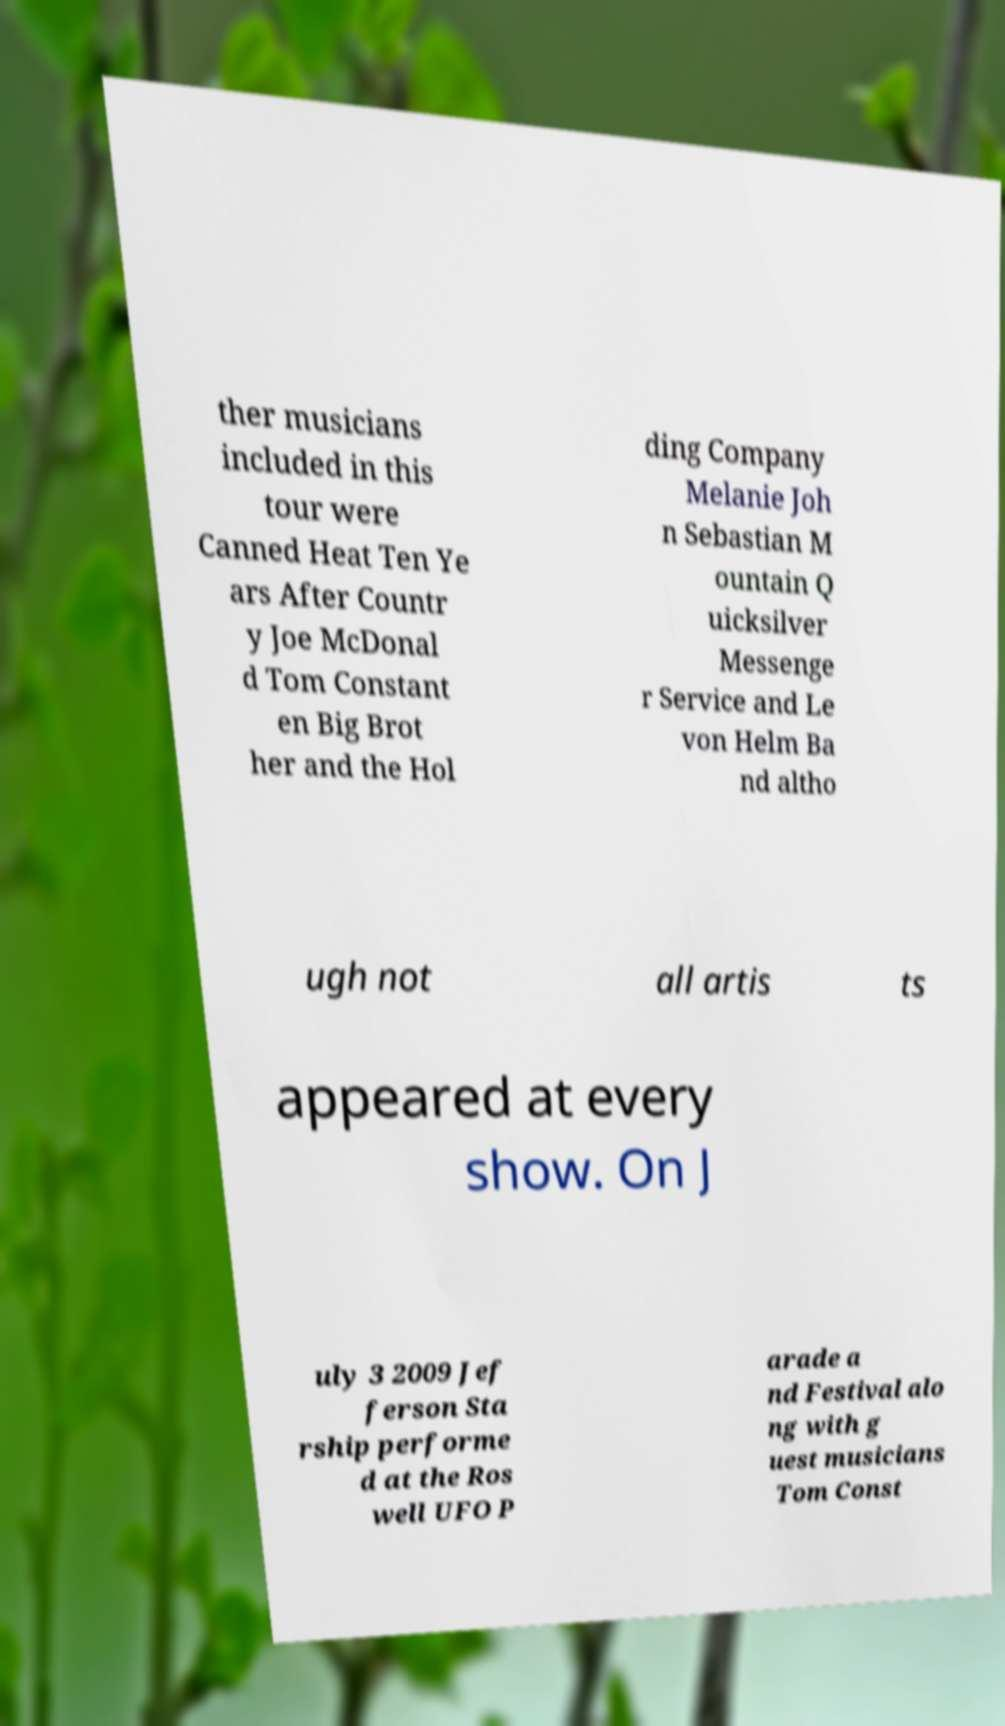For documentation purposes, I need the text within this image transcribed. Could you provide that? ther musicians included in this tour were Canned Heat Ten Ye ars After Countr y Joe McDonal d Tom Constant en Big Brot her and the Hol ding Company Melanie Joh n Sebastian M ountain Q uicksilver Messenge r Service and Le von Helm Ba nd altho ugh not all artis ts appeared at every show. On J uly 3 2009 Jef ferson Sta rship performe d at the Ros well UFO P arade a nd Festival alo ng with g uest musicians Tom Const 